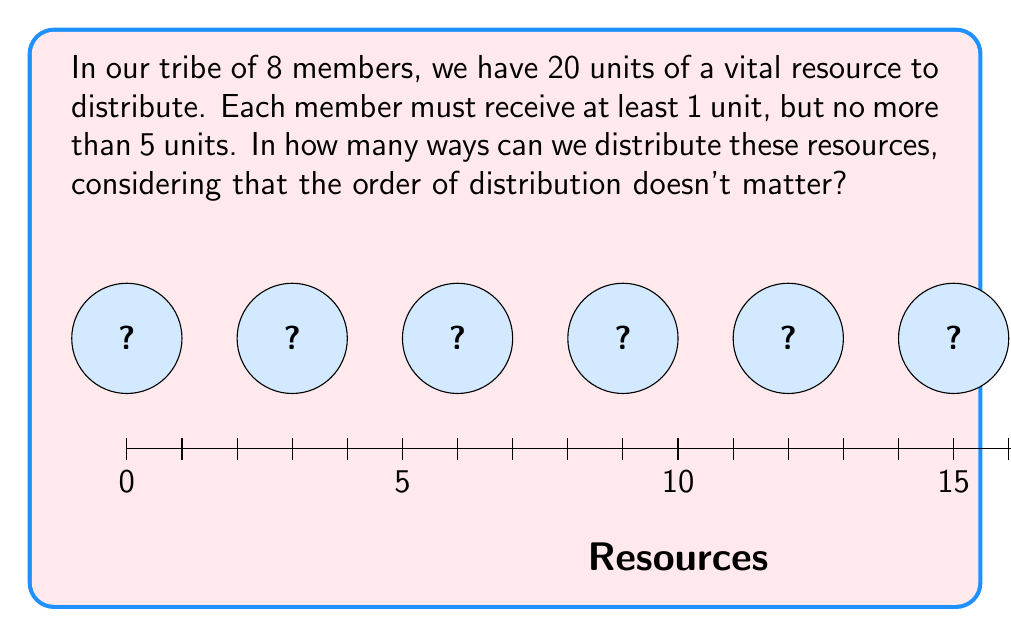Show me your answer to this math problem. Let's approach this step-by-step:

1) This is a problem of distributing indistinguishable objects (resources) into distinguishable boxes (tribe members) with restrictions. We can use the stars and bars method with modifications.

2) Let $x_i$ represent the number of resources given to the $i$-th member. We need to solve:

   $$x_1 + x_2 + ... + x_8 = 20$$

   Subject to: $1 \leq x_i \leq 5$ for all $i$

3) To satisfy the minimum condition, let's first give each member 1 unit:

   $$(x_1 + 1) + (x_2 + 1) + ... + (x_8 + 1) = 20 + 8 = 28$$

   Now we need to distribute the remaining 12 units, with each $x_i \leq 4$

4) Let $y_i = x_i + 1$. Then our problem becomes:

   $$y_1 + y_2 + ... + y_8 = 28$$

   Subject to: $1 \leq y_i \leq 5$ for all $i$

5) This is equivalent to finding the number of integer solutions to the above equation with the given constraints. We can use the principle of inclusion-exclusion.

6) Let $A_i$ be the set of solutions where $y_i \geq 6$. We want to find the complement of the union of all $A_i$.

7) By the principle of inclusion-exclusion:

   $$|\overline{\cup A_i}| = |U| - \sum |A_i| + \sum |A_i \cap A_j| - \sum |A_i \cap A_j \cap A_k| + ... + (-1)^8|A_1 \cap A_2 \cap ... \cap A_8|$$

8) $|U|$ is the total number of ways to distribute 28 indistinguishable objects into 8 distinguishable boxes: $\binom{28+7}{7} = \binom{35}{7}$

9) $|A_i|$ is the number of ways to distribute when one member gets 6 or more: $\binom{23+7}{7}$

10) $|A_i \cap A_j|$ is when two members get 6 or more: $\binom{18+7}{7}$

   And so on...

11) Putting it all together:

    $$\binom{35}{7} - \binom{8}{1}\binom{29}{7} + \binom{8}{2}\binom{23}{7} - \binom{8}{3}\binom{17}{7} + \binom{8}{4}\binom{11}{7} - \binom{8}{5}\binom{5}{5}$$

12) Calculating this gives us the final answer.
Answer: $$\binom{35}{7} - \binom{8}{1}\binom{29}{7} + \binom{8}{2}\binom{23}{7} - \binom{8}{3}\binom{17}{7} + \binom{8}{4}\binom{11}{7} - \binom{8}{5}\binom{5}{5} = 330$$ 